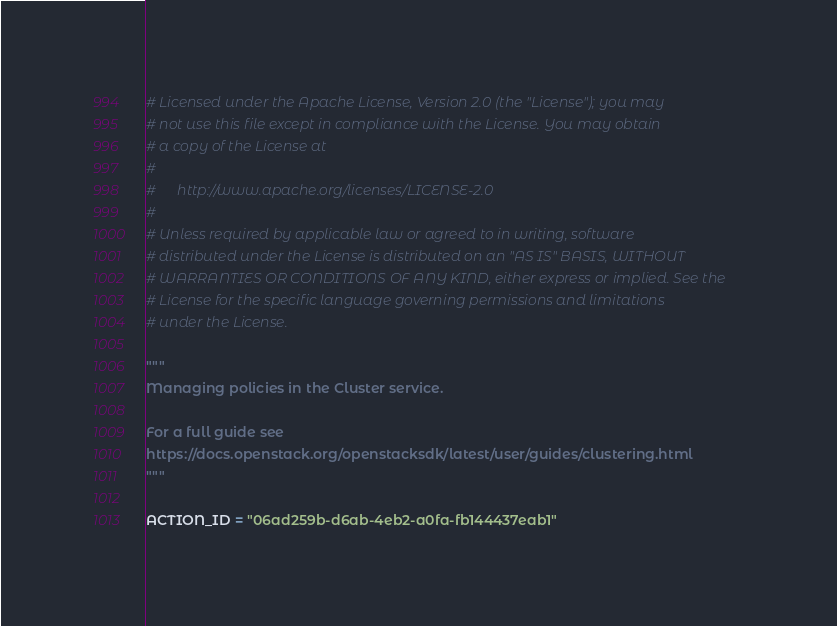<code> <loc_0><loc_0><loc_500><loc_500><_Python_># Licensed under the Apache License, Version 2.0 (the "License"); you may
# not use this file except in compliance with the License. You may obtain
# a copy of the License at
#
#      http://www.apache.org/licenses/LICENSE-2.0
#
# Unless required by applicable law or agreed to in writing, software
# distributed under the License is distributed on an "AS IS" BASIS, WITHOUT
# WARRANTIES OR CONDITIONS OF ANY KIND, either express or implied. See the
# License for the specific language governing permissions and limitations
# under the License.

"""
Managing policies in the Cluster service.

For a full guide see
https://docs.openstack.org/openstacksdk/latest/user/guides/clustering.html
"""

ACTION_ID = "06ad259b-d6ab-4eb2-a0fa-fb144437eab1"

</code> 